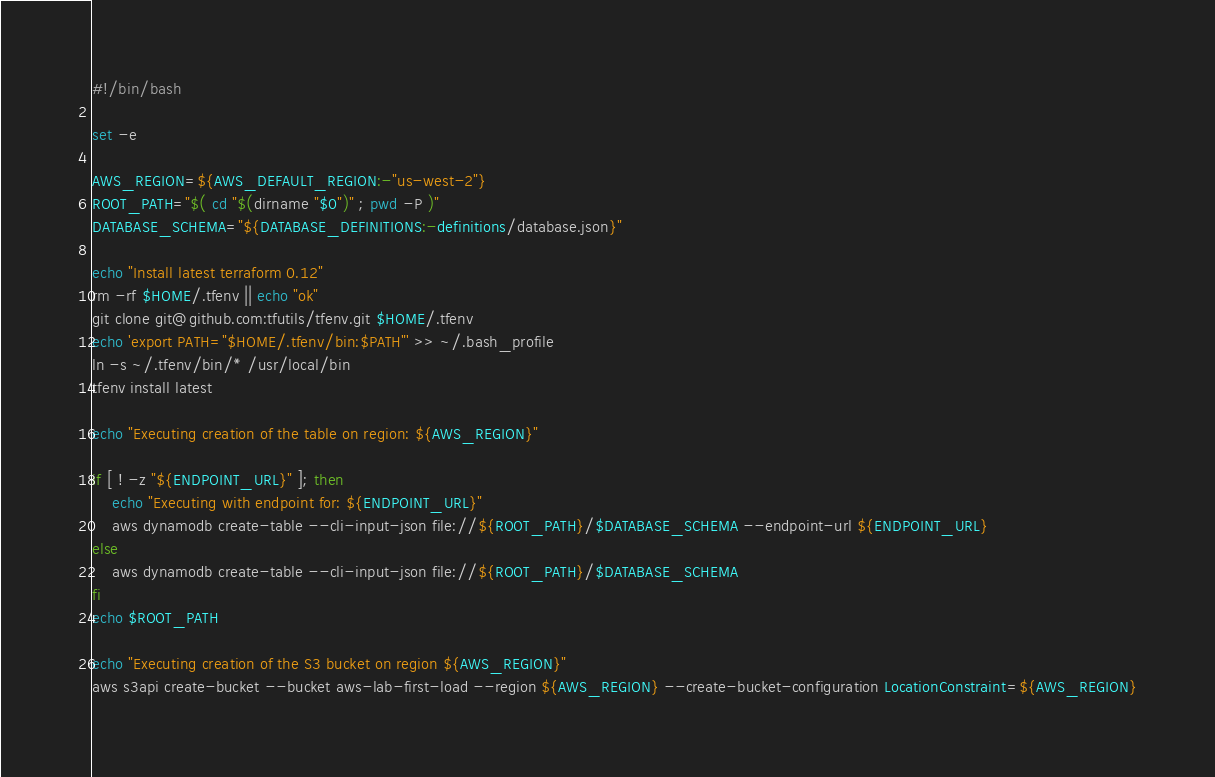<code> <loc_0><loc_0><loc_500><loc_500><_Bash_>#!/bin/bash

set -e

AWS_REGION=${AWS_DEFAULT_REGION:-"us-west-2"}
ROOT_PATH="$( cd "$(dirname "$0")" ; pwd -P )"
DATABASE_SCHEMA="${DATABASE_DEFINITIONS:-definitions/database.json}"

echo "Install latest terraform 0.12"
rm -rf $HOME/.tfenv || echo "ok"
git clone git@github.com:tfutils/tfenv.git $HOME/.tfenv
echo 'export PATH="$HOME/.tfenv/bin:$PATH"' >> ~/.bash_profile
ln -s ~/.tfenv/bin/* /usr/local/bin
tfenv install latest

echo "Executing creation of the table on region: ${AWS_REGION}"

if [ ! -z "${ENDPOINT_URL}" ]; then
	echo "Executing with endpoint for: ${ENDPOINT_URL}"
	aws dynamodb create-table --cli-input-json file://${ROOT_PATH}/$DATABASE_SCHEMA --endpoint-url ${ENDPOINT_URL}
else
	aws dynamodb create-table --cli-input-json file://${ROOT_PATH}/$DATABASE_SCHEMA
fi
echo $ROOT_PATH

echo "Executing creation of the S3 bucket on region ${AWS_REGION}"
aws s3api create-bucket --bucket aws-lab-first-load --region ${AWS_REGION} --create-bucket-configuration LocationConstraint=${AWS_REGION}
</code> 